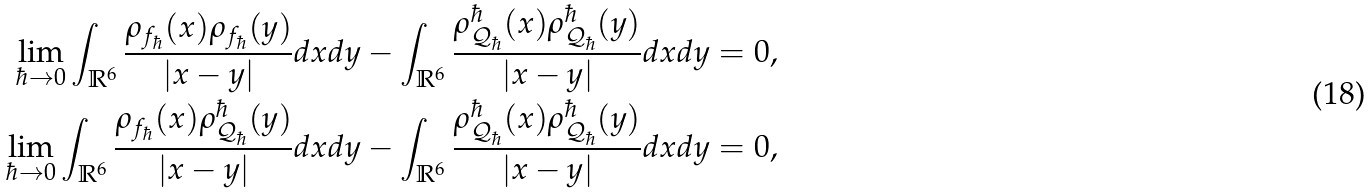Convert formula to latex. <formula><loc_0><loc_0><loc_500><loc_500>\lim _ { \hbar { \to } 0 } \int _ { \mathbb { R } ^ { 6 } } \frac { \rho _ { f _ { \hbar } } ( x ) \rho _ { f _ { \hbar } } ( y ) } { | x - y | } d x d y - \int _ { \mathbb { R } ^ { 6 } } \frac { \rho _ { \mathcal { Q } _ { \hbar } } ^ { \hbar } ( x ) \rho _ { \mathcal { Q } _ { \hbar } } ^ { \hbar } ( y ) } { | x - y | } d x d y & = 0 , \\ \lim _ { \hbar { \to } 0 } \int _ { \mathbb { R } ^ { 6 } } \frac { \rho _ { f _ { \hbar } } ( x ) \rho _ { \mathcal { Q } _ { \hbar } } ^ { \hbar } ( y ) } { | x - y | } d x d y - \int _ { \mathbb { R } ^ { 6 } } \frac { \rho _ { \mathcal { Q } _ { \hbar } } ^ { \hbar } ( x ) \rho _ { \mathcal { Q } _ { \hbar } } ^ { \hbar } ( y ) } { | x - y | } d x d y & = 0 ,</formula> 